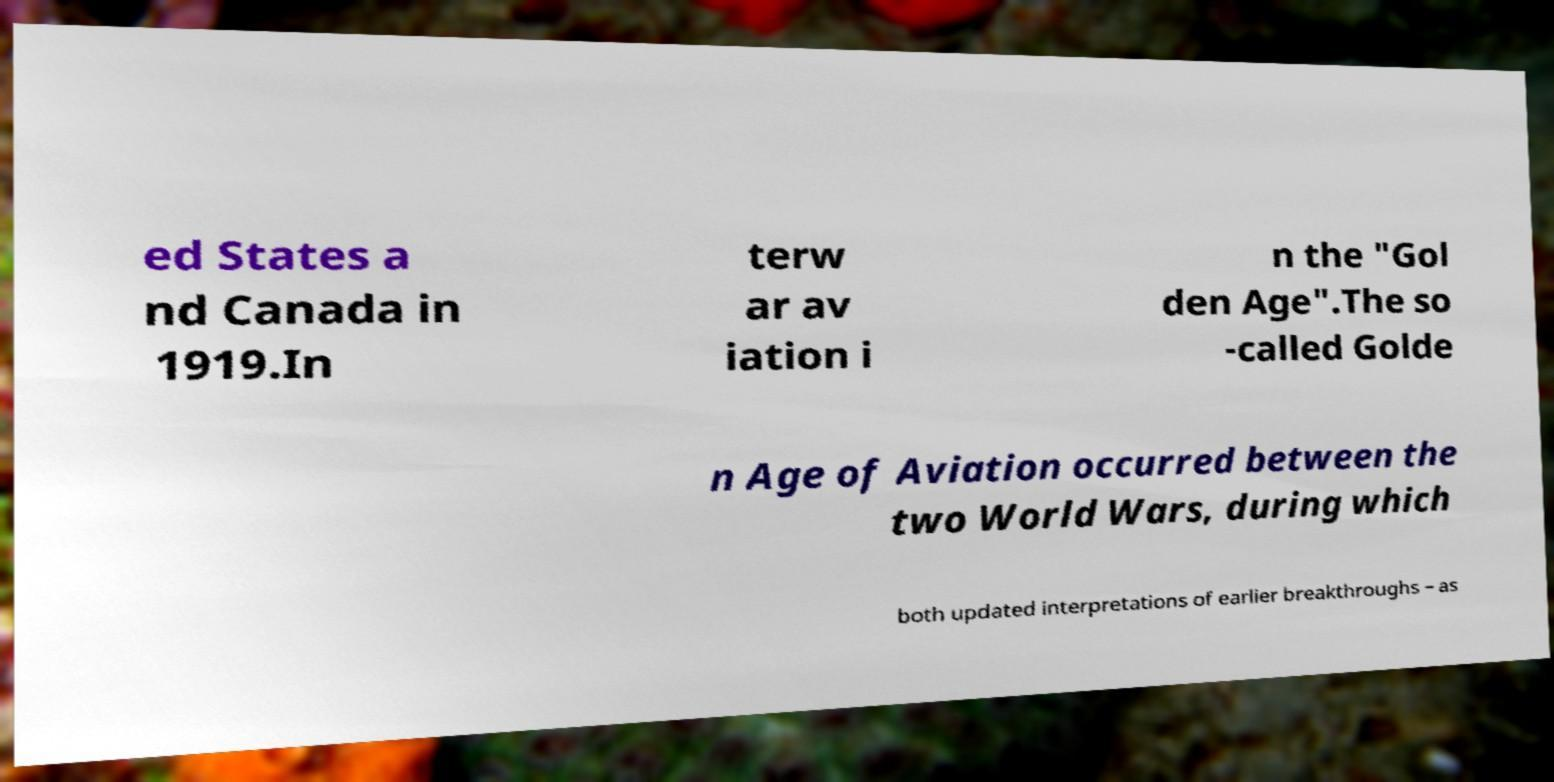Can you accurately transcribe the text from the provided image for me? ed States a nd Canada in 1919.In terw ar av iation i n the "Gol den Age".The so -called Golde n Age of Aviation occurred between the two World Wars, during which both updated interpretations of earlier breakthroughs – as 